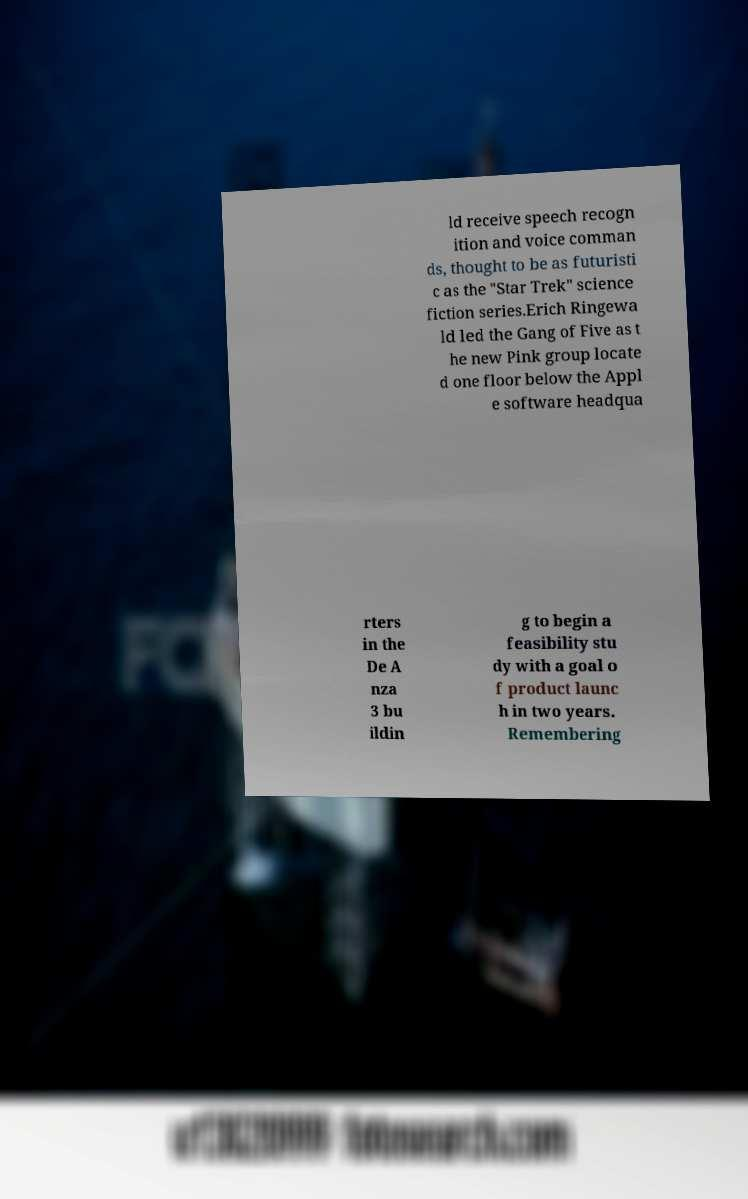Please read and relay the text visible in this image. What does it say? ld receive speech recogn ition and voice comman ds, thought to be as futuristi c as the "Star Trek" science fiction series.Erich Ringewa ld led the Gang of Five as t he new Pink group locate d one floor below the Appl e software headqua rters in the De A nza 3 bu ildin g to begin a feasibility stu dy with a goal o f product launc h in two years. Remembering 